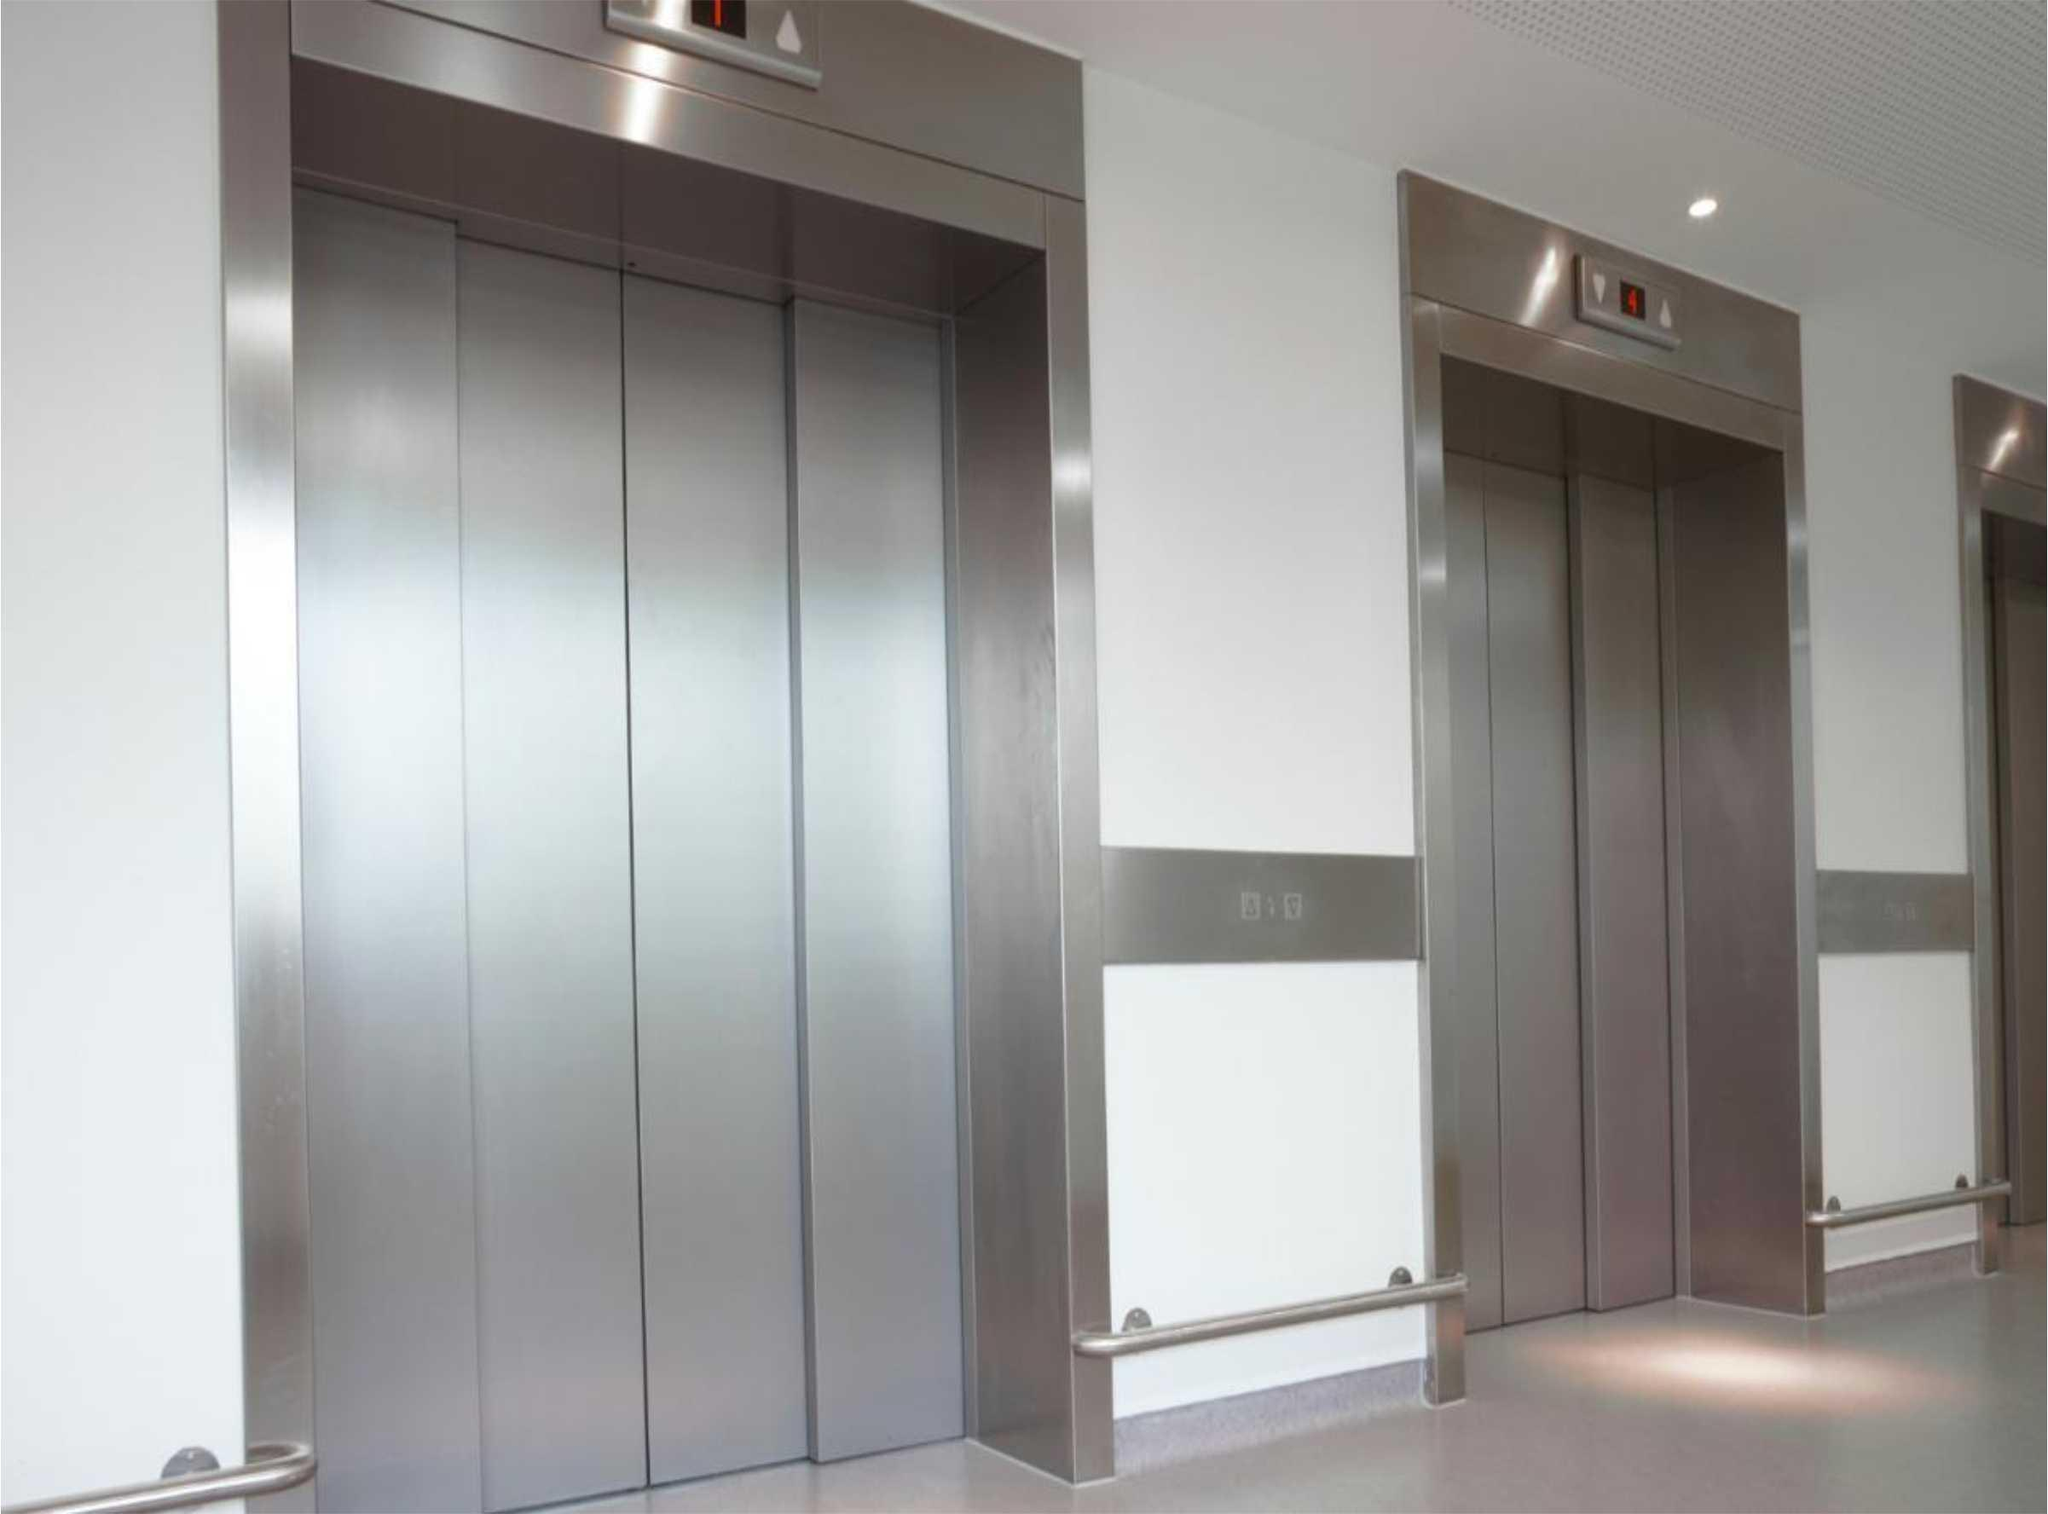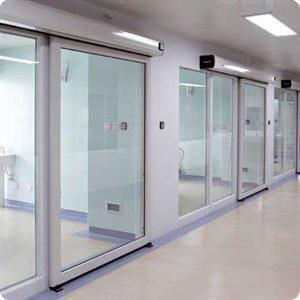The first image is the image on the left, the second image is the image on the right. Evaluate the accuracy of this statement regarding the images: "In at least one image there is a sliver elevator and the other image is ofwhite frame glass windows.". Is it true? Answer yes or no. Yes. The first image is the image on the left, the second image is the image on the right. Analyze the images presented: Is the assertion "One image features silver elevator doors, and the other image features glass windows that reach nearly to the ceiling." valid? Answer yes or no. Yes. 